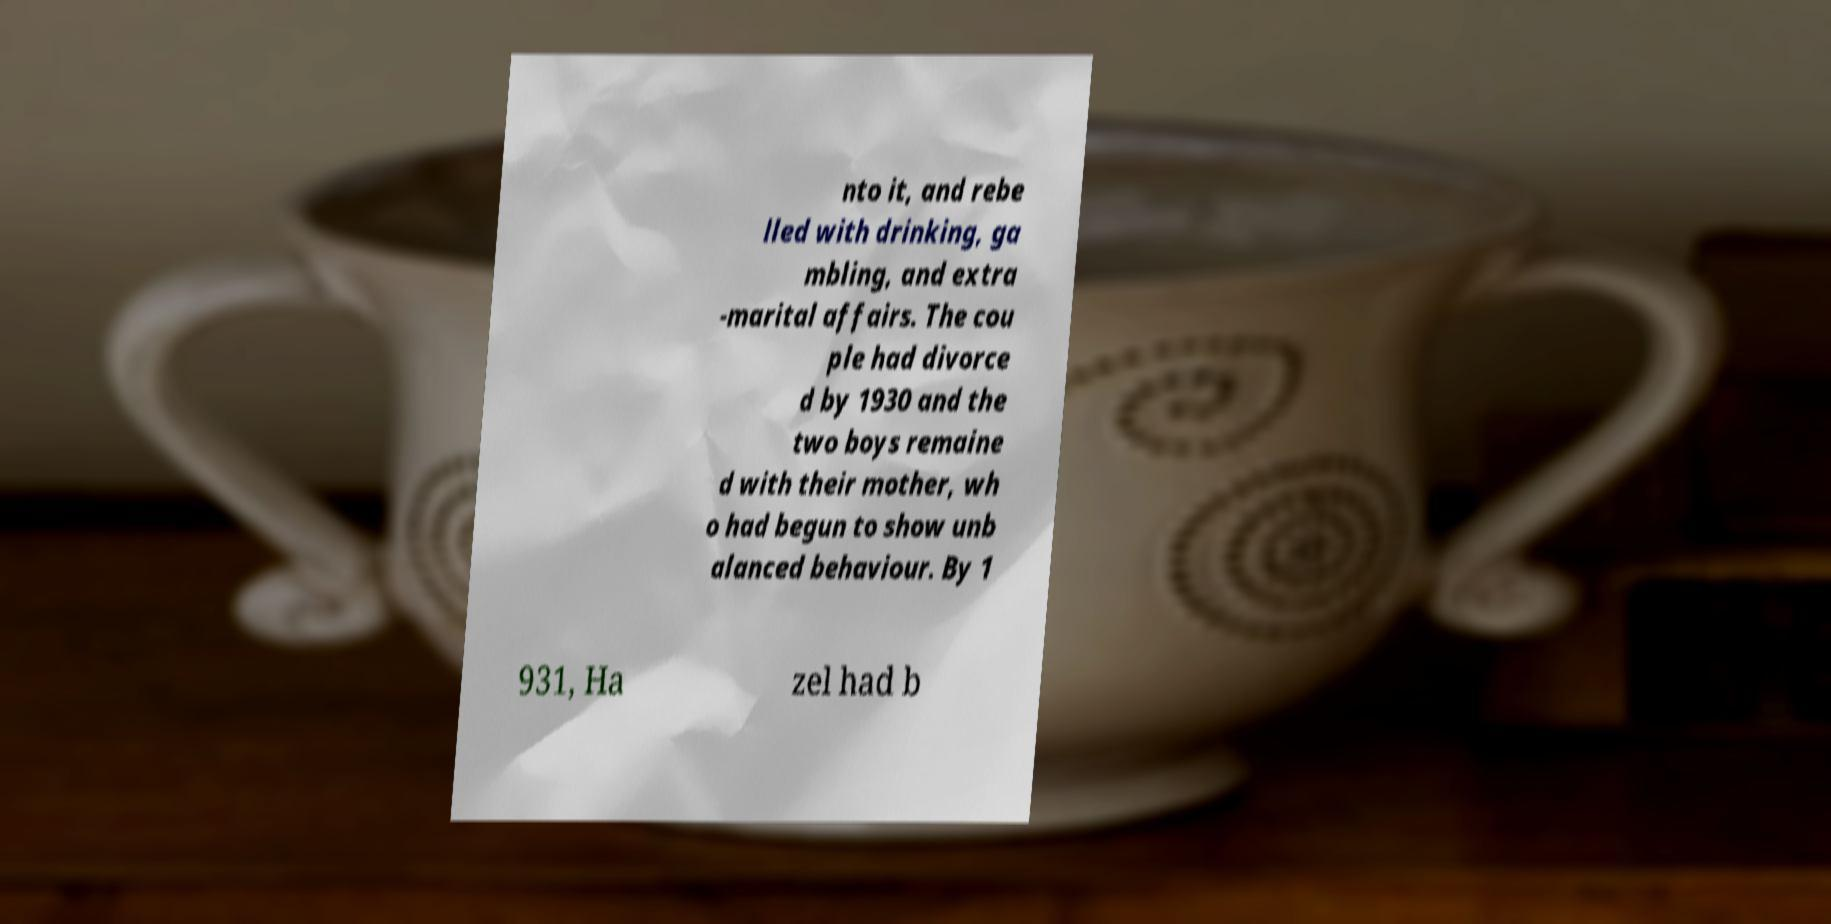Please identify and transcribe the text found in this image. nto it, and rebe lled with drinking, ga mbling, and extra -marital affairs. The cou ple had divorce d by 1930 and the two boys remaine d with their mother, wh o had begun to show unb alanced behaviour. By 1 931, Ha zel had b 